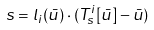Convert formula to latex. <formula><loc_0><loc_0><loc_500><loc_500>s = l _ { i } ( \bar { u } ) \cdot ( T ^ { i } _ { s } [ \bar { u } ] - \bar { u } )</formula> 